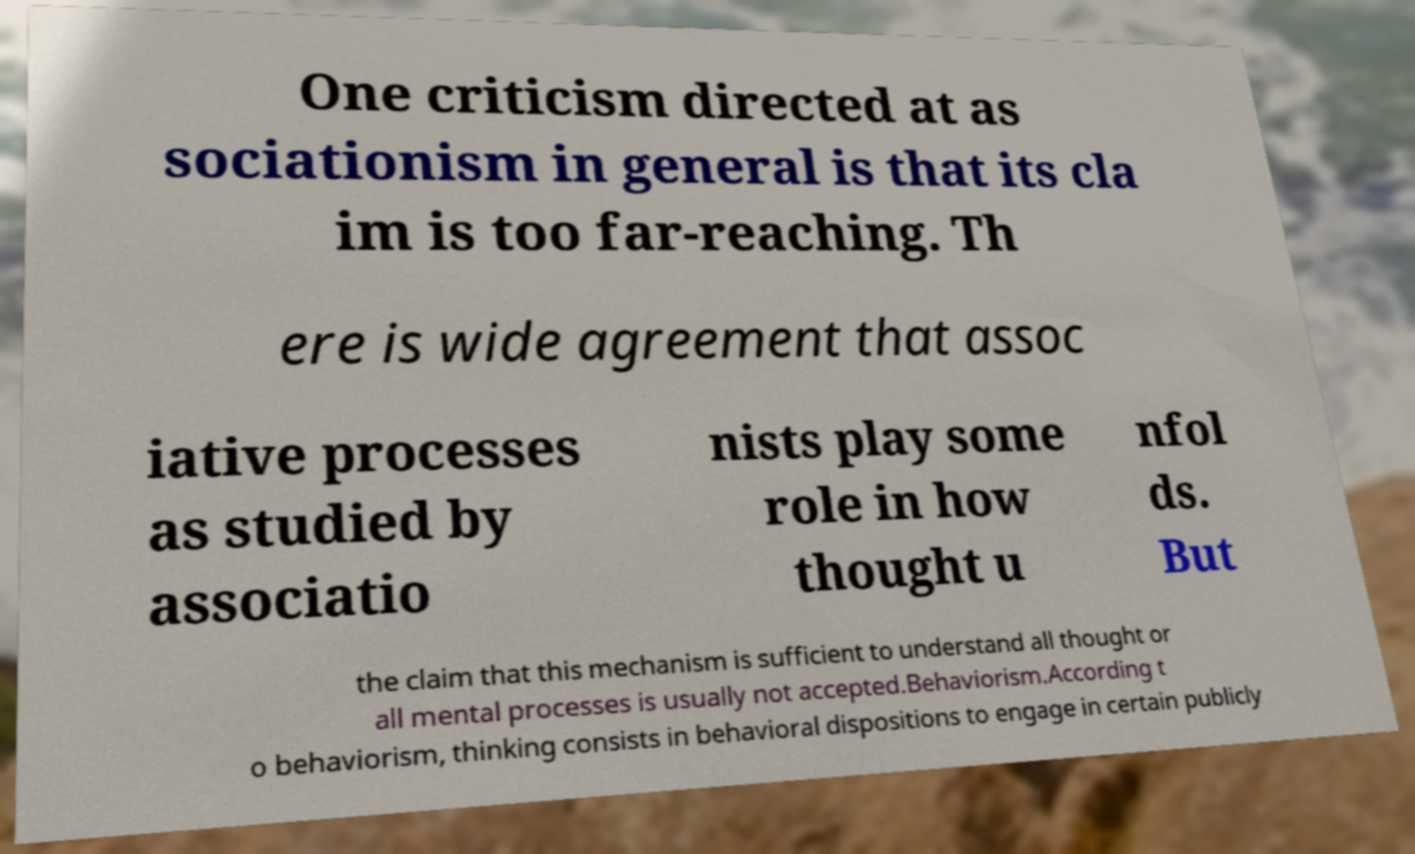What messages or text are displayed in this image? I need them in a readable, typed format. One criticism directed at as sociationism in general is that its cla im is too far-reaching. Th ere is wide agreement that assoc iative processes as studied by associatio nists play some role in how thought u nfol ds. But the claim that this mechanism is sufficient to understand all thought or all mental processes is usually not accepted.Behaviorism.According t o behaviorism, thinking consists in behavioral dispositions to engage in certain publicly 